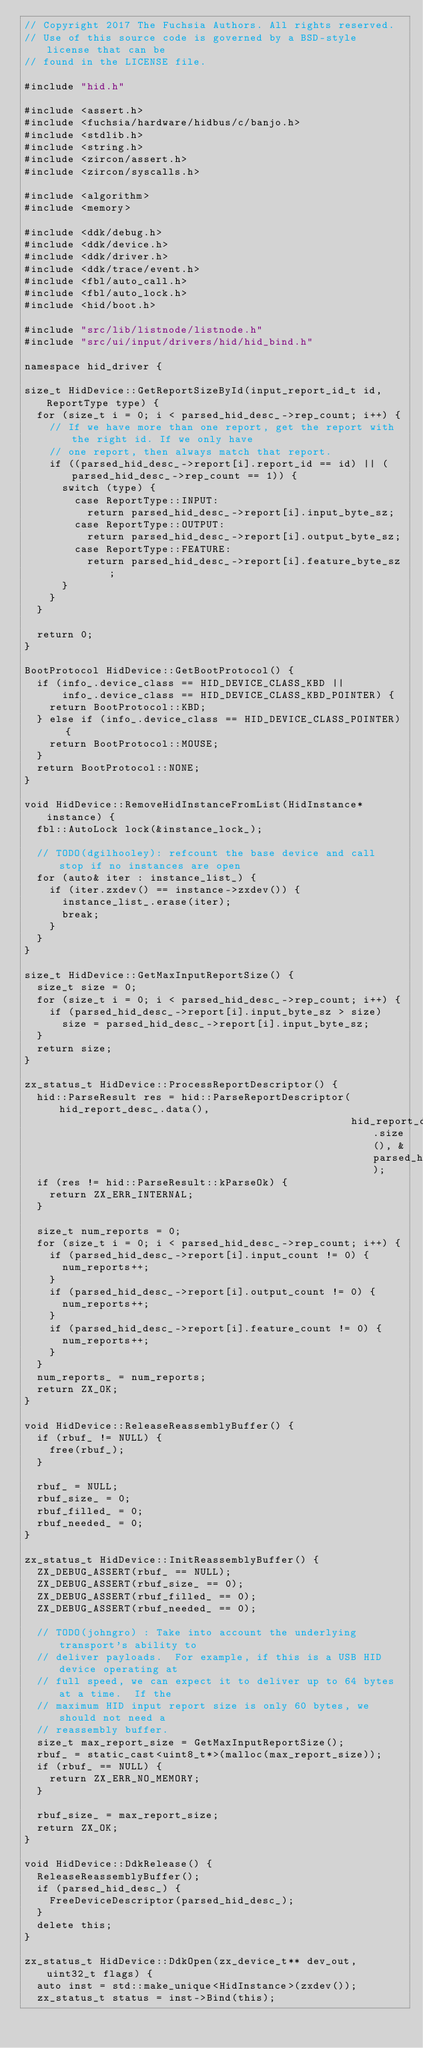<code> <loc_0><loc_0><loc_500><loc_500><_C++_>// Copyright 2017 The Fuchsia Authors. All rights reserved.
// Use of this source code is governed by a BSD-style license that can be
// found in the LICENSE file.

#include "hid.h"

#include <assert.h>
#include <fuchsia/hardware/hidbus/c/banjo.h>
#include <stdlib.h>
#include <string.h>
#include <zircon/assert.h>
#include <zircon/syscalls.h>

#include <algorithm>
#include <memory>

#include <ddk/debug.h>
#include <ddk/device.h>
#include <ddk/driver.h>
#include <ddk/trace/event.h>
#include <fbl/auto_call.h>
#include <fbl/auto_lock.h>
#include <hid/boot.h>

#include "src/lib/listnode/listnode.h"
#include "src/ui/input/drivers/hid/hid_bind.h"

namespace hid_driver {

size_t HidDevice::GetReportSizeById(input_report_id_t id, ReportType type) {
  for (size_t i = 0; i < parsed_hid_desc_->rep_count; i++) {
    // If we have more than one report, get the report with the right id. If we only have
    // one report, then always match that report.
    if ((parsed_hid_desc_->report[i].report_id == id) || (parsed_hid_desc_->rep_count == 1)) {
      switch (type) {
        case ReportType::INPUT:
          return parsed_hid_desc_->report[i].input_byte_sz;
        case ReportType::OUTPUT:
          return parsed_hid_desc_->report[i].output_byte_sz;
        case ReportType::FEATURE:
          return parsed_hid_desc_->report[i].feature_byte_sz;
      }
    }
  }

  return 0;
}

BootProtocol HidDevice::GetBootProtocol() {
  if (info_.device_class == HID_DEVICE_CLASS_KBD ||
      info_.device_class == HID_DEVICE_CLASS_KBD_POINTER) {
    return BootProtocol::KBD;
  } else if (info_.device_class == HID_DEVICE_CLASS_POINTER) {
    return BootProtocol::MOUSE;
  }
  return BootProtocol::NONE;
}

void HidDevice::RemoveHidInstanceFromList(HidInstance* instance) {
  fbl::AutoLock lock(&instance_lock_);

  // TODO(dgilhooley): refcount the base device and call stop if no instances are open
  for (auto& iter : instance_list_) {
    if (iter.zxdev() == instance->zxdev()) {
      instance_list_.erase(iter);
      break;
    }
  }
}

size_t HidDevice::GetMaxInputReportSize() {
  size_t size = 0;
  for (size_t i = 0; i < parsed_hid_desc_->rep_count; i++) {
    if (parsed_hid_desc_->report[i].input_byte_sz > size)
      size = parsed_hid_desc_->report[i].input_byte_sz;
  }
  return size;
}

zx_status_t HidDevice::ProcessReportDescriptor() {
  hid::ParseResult res = hid::ParseReportDescriptor(hid_report_desc_.data(),
                                                    hid_report_desc_.size(), &parsed_hid_desc_);
  if (res != hid::ParseResult::kParseOk) {
    return ZX_ERR_INTERNAL;
  }

  size_t num_reports = 0;
  for (size_t i = 0; i < parsed_hid_desc_->rep_count; i++) {
    if (parsed_hid_desc_->report[i].input_count != 0) {
      num_reports++;
    }
    if (parsed_hid_desc_->report[i].output_count != 0) {
      num_reports++;
    }
    if (parsed_hid_desc_->report[i].feature_count != 0) {
      num_reports++;
    }
  }
  num_reports_ = num_reports;
  return ZX_OK;
}

void HidDevice::ReleaseReassemblyBuffer() {
  if (rbuf_ != NULL) {
    free(rbuf_);
  }

  rbuf_ = NULL;
  rbuf_size_ = 0;
  rbuf_filled_ = 0;
  rbuf_needed_ = 0;
}

zx_status_t HidDevice::InitReassemblyBuffer() {
  ZX_DEBUG_ASSERT(rbuf_ == NULL);
  ZX_DEBUG_ASSERT(rbuf_size_ == 0);
  ZX_DEBUG_ASSERT(rbuf_filled_ == 0);
  ZX_DEBUG_ASSERT(rbuf_needed_ == 0);

  // TODO(johngro) : Take into account the underlying transport's ability to
  // deliver payloads.  For example, if this is a USB HID device operating at
  // full speed, we can expect it to deliver up to 64 bytes at a time.  If the
  // maximum HID input report size is only 60 bytes, we should not need a
  // reassembly buffer.
  size_t max_report_size = GetMaxInputReportSize();
  rbuf_ = static_cast<uint8_t*>(malloc(max_report_size));
  if (rbuf_ == NULL) {
    return ZX_ERR_NO_MEMORY;
  }

  rbuf_size_ = max_report_size;
  return ZX_OK;
}

void HidDevice::DdkRelease() {
  ReleaseReassemblyBuffer();
  if (parsed_hid_desc_) {
    FreeDeviceDescriptor(parsed_hid_desc_);
  }
  delete this;
}

zx_status_t HidDevice::DdkOpen(zx_device_t** dev_out, uint32_t flags) {
  auto inst = std::make_unique<HidInstance>(zxdev());
  zx_status_t status = inst->Bind(this);</code> 